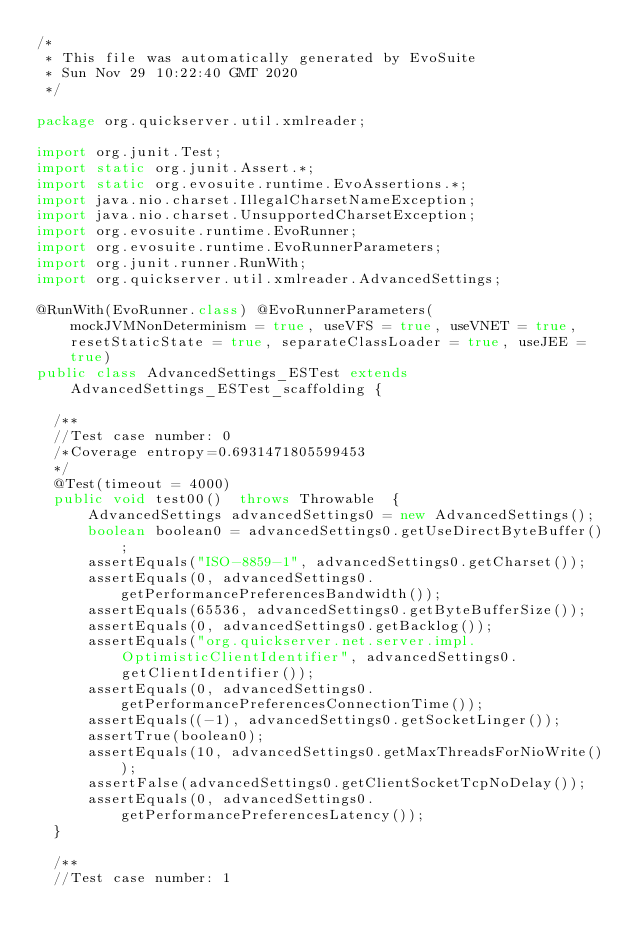<code> <loc_0><loc_0><loc_500><loc_500><_Java_>/*
 * This file was automatically generated by EvoSuite
 * Sun Nov 29 10:22:40 GMT 2020
 */

package org.quickserver.util.xmlreader;

import org.junit.Test;
import static org.junit.Assert.*;
import static org.evosuite.runtime.EvoAssertions.*;
import java.nio.charset.IllegalCharsetNameException;
import java.nio.charset.UnsupportedCharsetException;
import org.evosuite.runtime.EvoRunner;
import org.evosuite.runtime.EvoRunnerParameters;
import org.junit.runner.RunWith;
import org.quickserver.util.xmlreader.AdvancedSettings;

@RunWith(EvoRunner.class) @EvoRunnerParameters(mockJVMNonDeterminism = true, useVFS = true, useVNET = true, resetStaticState = true, separateClassLoader = true, useJEE = true) 
public class AdvancedSettings_ESTest extends AdvancedSettings_ESTest_scaffolding {

  /**
  //Test case number: 0
  /*Coverage entropy=0.6931471805599453
  */
  @Test(timeout = 4000)
  public void test00()  throws Throwable  {
      AdvancedSettings advancedSettings0 = new AdvancedSettings();
      boolean boolean0 = advancedSettings0.getUseDirectByteBuffer();
      assertEquals("ISO-8859-1", advancedSettings0.getCharset());
      assertEquals(0, advancedSettings0.getPerformancePreferencesBandwidth());
      assertEquals(65536, advancedSettings0.getByteBufferSize());
      assertEquals(0, advancedSettings0.getBacklog());
      assertEquals("org.quickserver.net.server.impl.OptimisticClientIdentifier", advancedSettings0.getClientIdentifier());
      assertEquals(0, advancedSettings0.getPerformancePreferencesConnectionTime());
      assertEquals((-1), advancedSettings0.getSocketLinger());
      assertTrue(boolean0);
      assertEquals(10, advancedSettings0.getMaxThreadsForNioWrite());
      assertFalse(advancedSettings0.getClientSocketTcpNoDelay());
      assertEquals(0, advancedSettings0.getPerformancePreferencesLatency());
  }

  /**
  //Test case number: 1</code> 